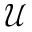Convert formula to latex. <formula><loc_0><loc_0><loc_500><loc_500>\mathcal { U }</formula> 